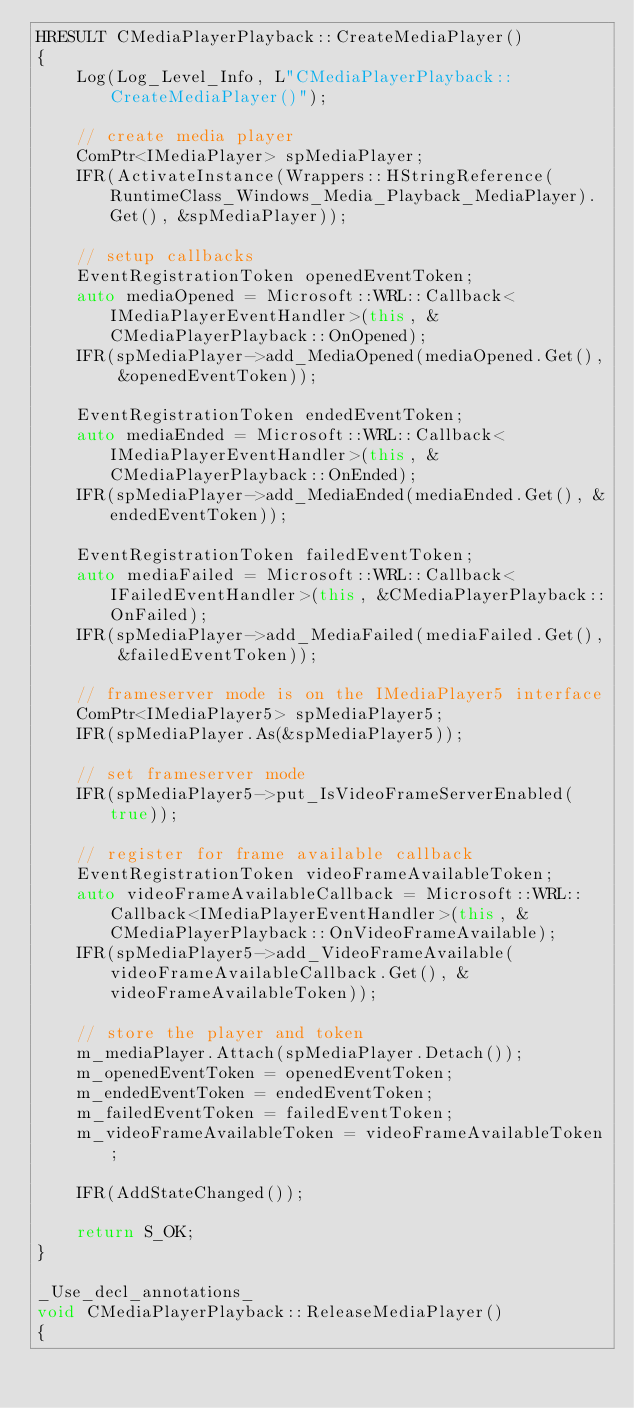Convert code to text. <code><loc_0><loc_0><loc_500><loc_500><_C++_>HRESULT CMediaPlayerPlayback::CreateMediaPlayer()
{
    Log(Log_Level_Info, L"CMediaPlayerPlayback::CreateMediaPlayer()");

    // create media player
    ComPtr<IMediaPlayer> spMediaPlayer;
    IFR(ActivateInstance(Wrappers::HStringReference(RuntimeClass_Windows_Media_Playback_MediaPlayer).Get(), &spMediaPlayer));

    // setup callbacks
    EventRegistrationToken openedEventToken;
    auto mediaOpened = Microsoft::WRL::Callback<IMediaPlayerEventHandler>(this, &CMediaPlayerPlayback::OnOpened);
    IFR(spMediaPlayer->add_MediaOpened(mediaOpened.Get(), &openedEventToken));

    EventRegistrationToken endedEventToken;
    auto mediaEnded = Microsoft::WRL::Callback<IMediaPlayerEventHandler>(this, &CMediaPlayerPlayback::OnEnded);
    IFR(spMediaPlayer->add_MediaEnded(mediaEnded.Get(), &endedEventToken));

    EventRegistrationToken failedEventToken;
    auto mediaFailed = Microsoft::WRL::Callback<IFailedEventHandler>(this, &CMediaPlayerPlayback::OnFailed);
    IFR(spMediaPlayer->add_MediaFailed(mediaFailed.Get(), &failedEventToken));

    // frameserver mode is on the IMediaPlayer5 interface
    ComPtr<IMediaPlayer5> spMediaPlayer5;
    IFR(spMediaPlayer.As(&spMediaPlayer5));

    // set frameserver mode
    IFR(spMediaPlayer5->put_IsVideoFrameServerEnabled(true));

    // register for frame available callback
    EventRegistrationToken videoFrameAvailableToken;
    auto videoFrameAvailableCallback = Microsoft::WRL::Callback<IMediaPlayerEventHandler>(this, &CMediaPlayerPlayback::OnVideoFrameAvailable);
    IFR(spMediaPlayer5->add_VideoFrameAvailable(videoFrameAvailableCallback.Get(), &videoFrameAvailableToken));

    // store the player and token
    m_mediaPlayer.Attach(spMediaPlayer.Detach());
    m_openedEventToken = openedEventToken;
    m_endedEventToken = endedEventToken;
    m_failedEventToken = failedEventToken;
    m_videoFrameAvailableToken = videoFrameAvailableToken;

    IFR(AddStateChanged());

    return S_OK;
}

_Use_decl_annotations_
void CMediaPlayerPlayback::ReleaseMediaPlayer()
{</code> 